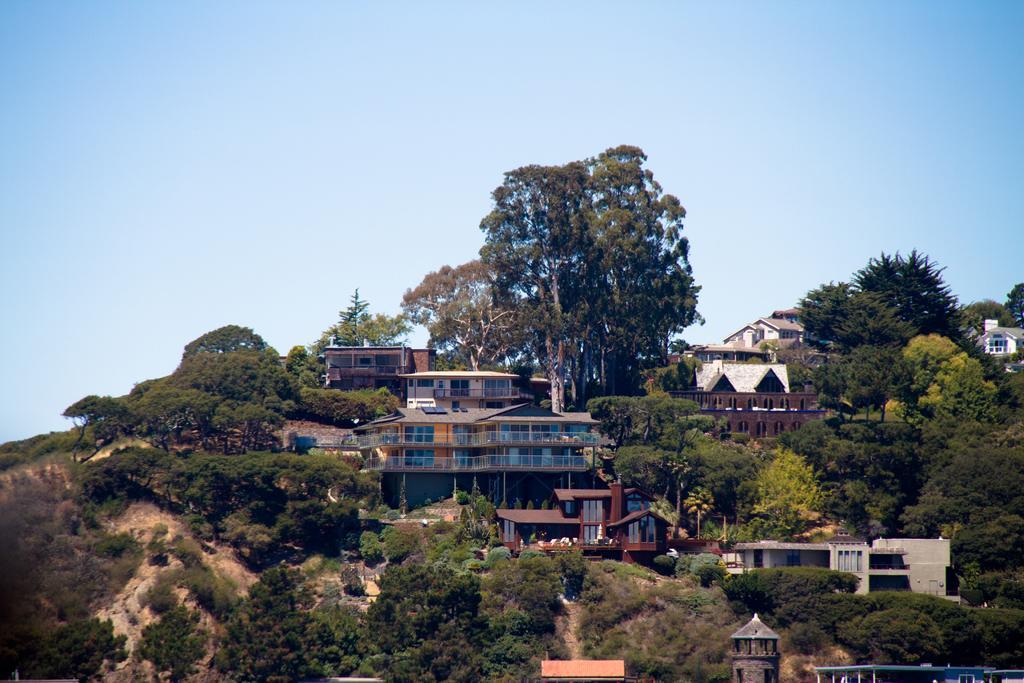How would you summarize this image in a sentence or two? In this image, we can see buildings, trees, sheds, a bench, tower and there are hills. At the top, there is sky. 